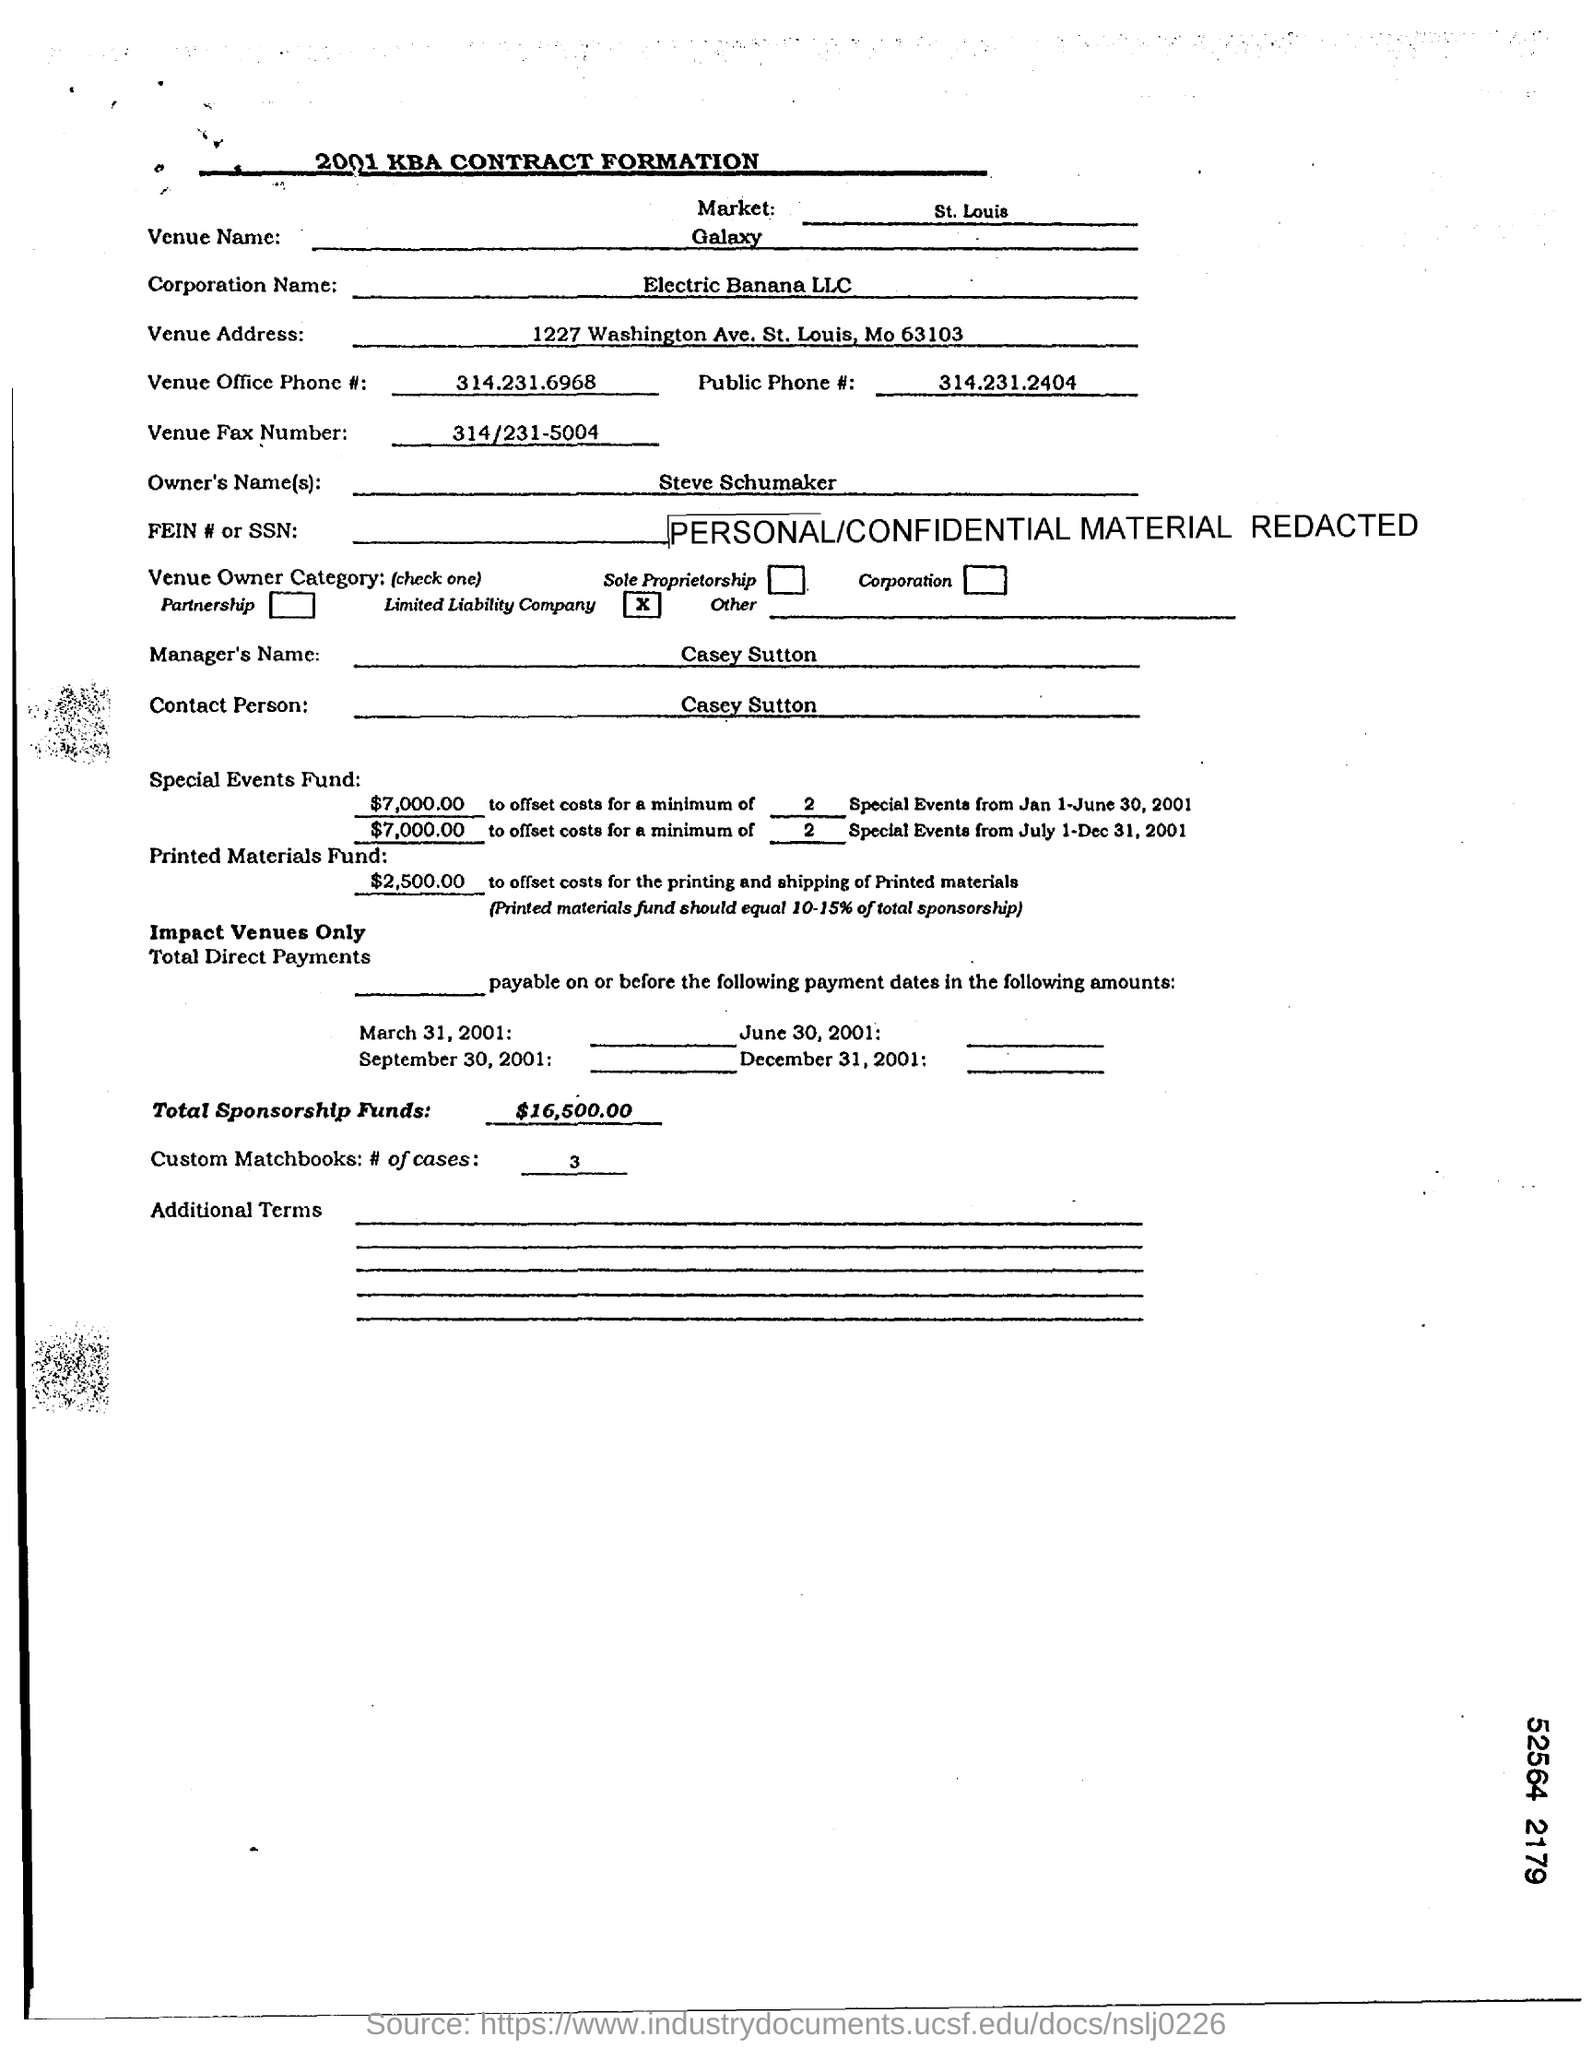Highlight a few significant elements in this photo. I want to know the phone number of the Venue Office which is 314.231.6968. The Venue Name is Galaxy. The document provides the name "Steve Schumaker" as the owner. The name of the corporation is Electric Banana LLC. The St. Louis market is a dynamic and diverse economic hub that offers a wide range of opportunities for businesses and individuals alike. 